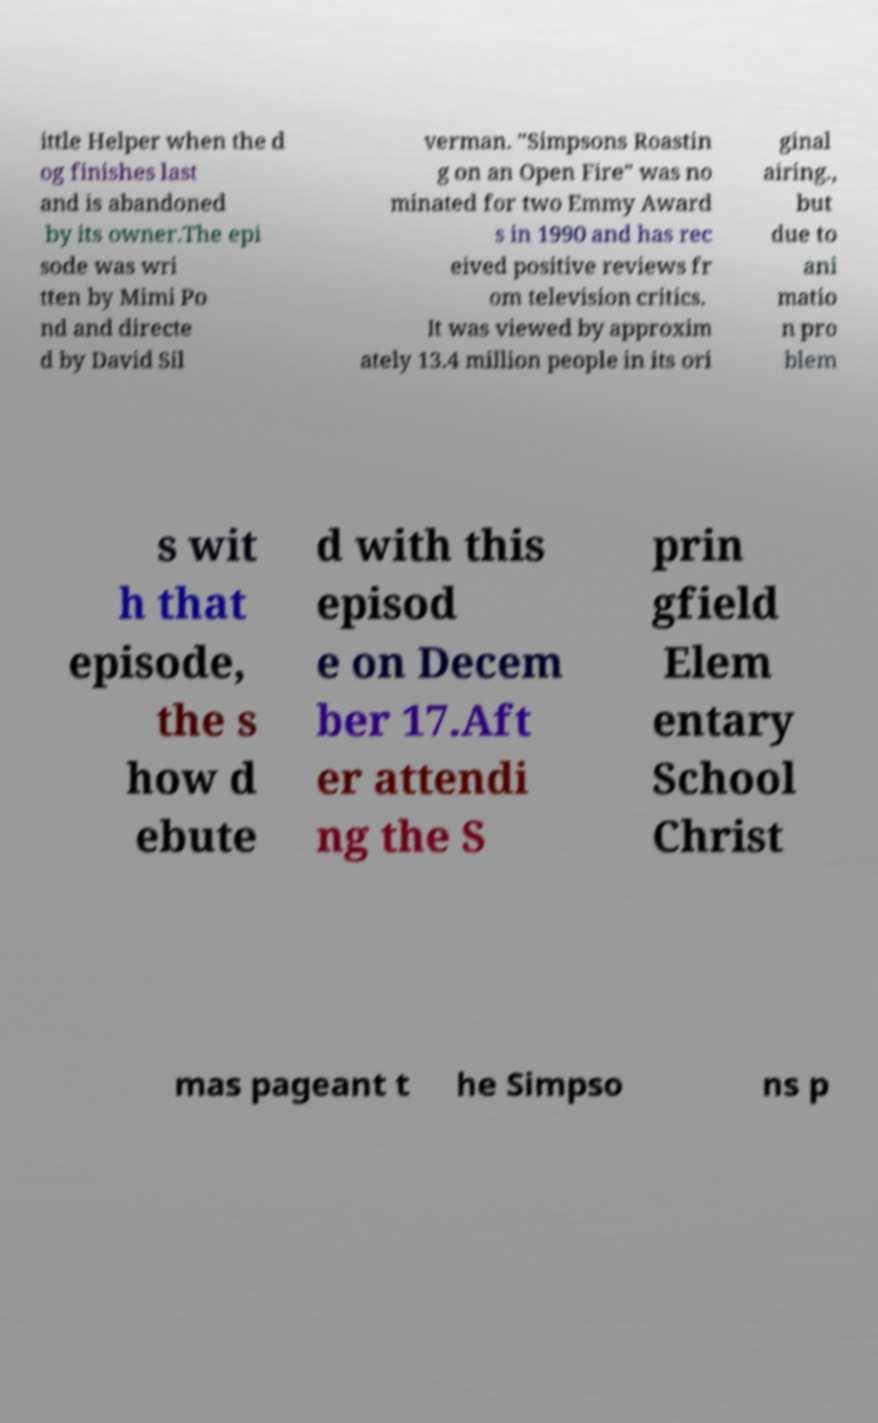I need the written content from this picture converted into text. Can you do that? ittle Helper when the d og finishes last and is abandoned by its owner.The epi sode was wri tten by Mimi Po nd and directe d by David Sil verman. "Simpsons Roastin g on an Open Fire" was no minated for two Emmy Award s in 1990 and has rec eived positive reviews fr om television critics. It was viewed by approxim ately 13.4 million people in its ori ginal airing., but due to ani matio n pro blem s wit h that episode, the s how d ebute d with this episod e on Decem ber 17.Aft er attendi ng the S prin gfield Elem entary School Christ mas pageant t he Simpso ns p 